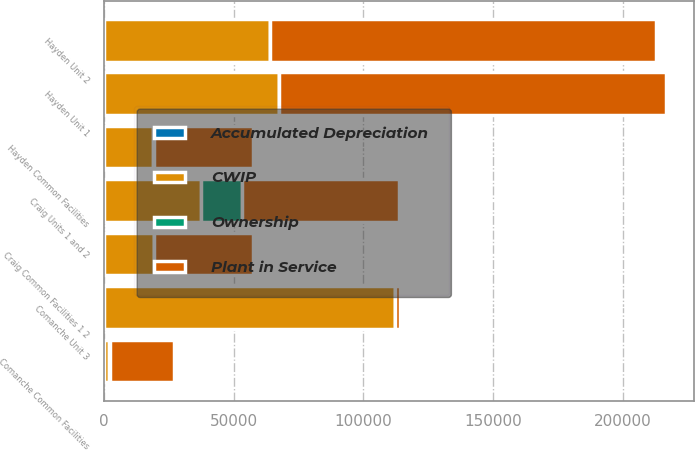Convert chart to OTSL. <chart><loc_0><loc_0><loc_500><loc_500><stacked_bar_chart><ecel><fcel>Hayden Unit 1<fcel>Hayden Unit 2<fcel>Hayden Common Facilities<fcel>Craig Units 1 and 2<fcel>Craig Common Facilities 1 2<fcel>Comanche Unit 3<fcel>Comanche Common Facilities<nl><fcel>Plant in Service<fcel>149221<fcel>148795<fcel>38230<fcel>60318<fcel>37925<fcel>1821<fcel>24694<nl><fcel>CWIP<fcel>67415<fcel>64024<fcel>18951<fcel>37570<fcel>19312<fcel>112254<fcel>1821<nl><fcel>Ownership<fcel>97<fcel>64<fcel>282<fcel>15730<fcel>183<fcel>6<fcel>636<nl><fcel>Accumulated Depreciation<fcel>76<fcel>37<fcel>53<fcel>10<fcel>7<fcel>67<fcel>82<nl></chart> 